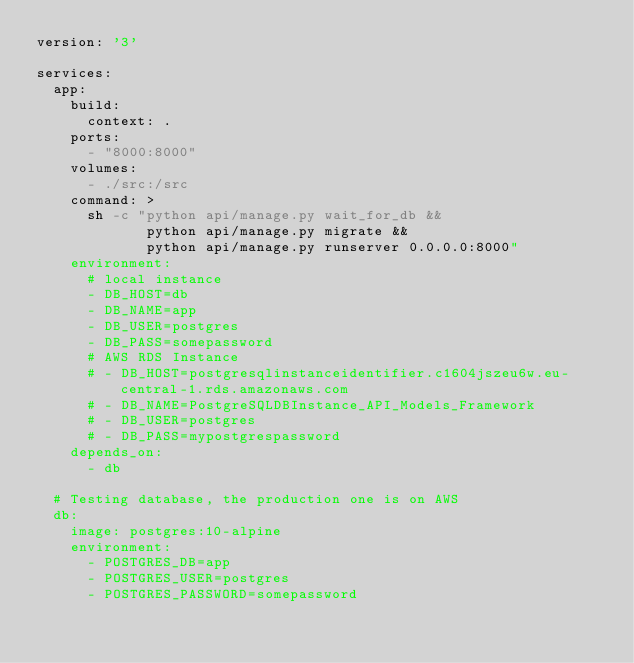Convert code to text. <code><loc_0><loc_0><loc_500><loc_500><_YAML_>version: '3'

services:
  app:
    build:
      context: .
    ports:
      - "8000:8000"
    volumes:
      - ./src:/src
    command: >
      sh -c "python api/manage.py wait_for_db &&
             python api/manage.py migrate &&
             python api/manage.py runserver 0.0.0.0:8000"
    environment:
      # local instance
      - DB_HOST=db
      - DB_NAME=app
      - DB_USER=postgres
      - DB_PASS=somepassword
      # AWS RDS Instance
      # - DB_HOST=postgresqlinstanceidentifier.c1604jszeu6w.eu-central-1.rds.amazonaws.com
      # - DB_NAME=PostgreSQLDBInstance_API_Models_Framework
      # - DB_USER=postgres
      # - DB_PASS=mypostgrespassword
    depends_on:
      - db

  # Testing database, the production one is on AWS
  db:
    image: postgres:10-alpine
    environment:
      - POSTGRES_DB=app
      - POSTGRES_USER=postgres
      - POSTGRES_PASSWORD=somepassword
</code> 